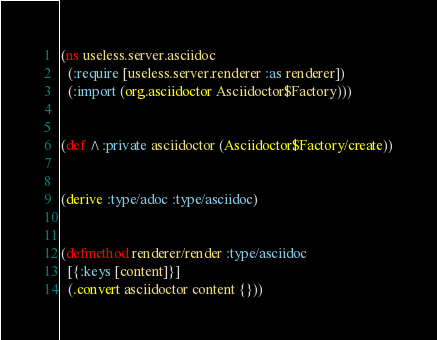<code> <loc_0><loc_0><loc_500><loc_500><_Clojure_>(ns useless.server.asciidoc
  (:require [useless.server.renderer :as renderer])
  (:import (org.asciidoctor Asciidoctor$Factory)))


(def ^:private asciidoctor (Asciidoctor$Factory/create))


(derive :type/adoc :type/asciidoc)


(defmethod renderer/render :type/asciidoc
  [{:keys [content]}]
  (.convert asciidoctor content {}))
</code> 